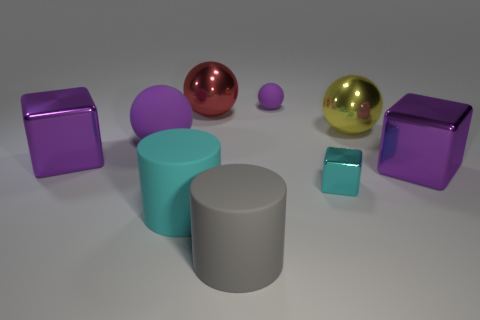Subtract all large purple shiny cubes. How many cubes are left? 1 Subtract all red spheres. How many spheres are left? 3 Subtract 2 cylinders. How many cylinders are left? 0 Subtract all cubes. How many objects are left? 6 Subtract all purple spheres. How many cyan cylinders are left? 1 Subtract all big metallic objects. Subtract all big purple metal things. How many objects are left? 3 Add 7 metallic spheres. How many metallic spheres are left? 9 Add 5 blue matte things. How many blue matte things exist? 5 Subtract 0 brown balls. How many objects are left? 9 Subtract all cyan balls. Subtract all gray blocks. How many balls are left? 4 